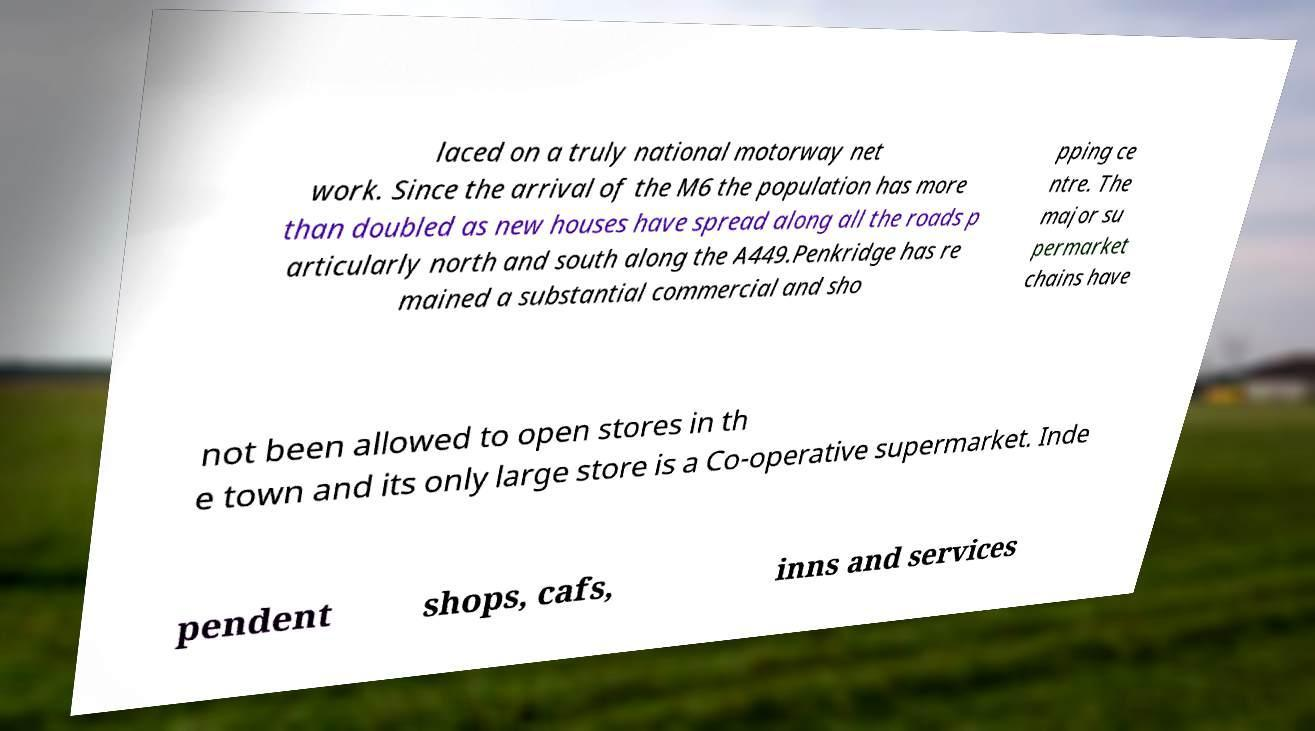For documentation purposes, I need the text within this image transcribed. Could you provide that? laced on a truly national motorway net work. Since the arrival of the M6 the population has more than doubled as new houses have spread along all the roads p articularly north and south along the A449.Penkridge has re mained a substantial commercial and sho pping ce ntre. The major su permarket chains have not been allowed to open stores in th e town and its only large store is a Co-operative supermarket. Inde pendent shops, cafs, inns and services 